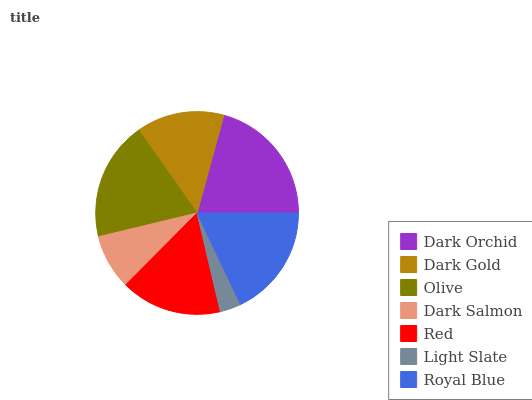Is Light Slate the minimum?
Answer yes or no. Yes. Is Dark Orchid the maximum?
Answer yes or no. Yes. Is Dark Gold the minimum?
Answer yes or no. No. Is Dark Gold the maximum?
Answer yes or no. No. Is Dark Orchid greater than Dark Gold?
Answer yes or no. Yes. Is Dark Gold less than Dark Orchid?
Answer yes or no. Yes. Is Dark Gold greater than Dark Orchid?
Answer yes or no. No. Is Dark Orchid less than Dark Gold?
Answer yes or no. No. Is Red the high median?
Answer yes or no. Yes. Is Red the low median?
Answer yes or no. Yes. Is Dark Gold the high median?
Answer yes or no. No. Is Dark Orchid the low median?
Answer yes or no. No. 